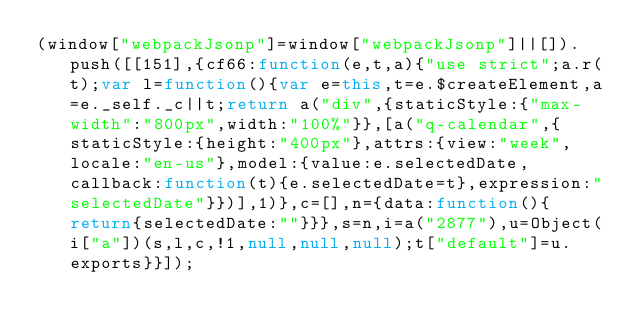<code> <loc_0><loc_0><loc_500><loc_500><_JavaScript_>(window["webpackJsonp"]=window["webpackJsonp"]||[]).push([[151],{cf66:function(e,t,a){"use strict";a.r(t);var l=function(){var e=this,t=e.$createElement,a=e._self._c||t;return a("div",{staticStyle:{"max-width":"800px",width:"100%"}},[a("q-calendar",{staticStyle:{height:"400px"},attrs:{view:"week",locale:"en-us"},model:{value:e.selectedDate,callback:function(t){e.selectedDate=t},expression:"selectedDate"}})],1)},c=[],n={data:function(){return{selectedDate:""}}},s=n,i=a("2877"),u=Object(i["a"])(s,l,c,!1,null,null,null);t["default"]=u.exports}}]);</code> 